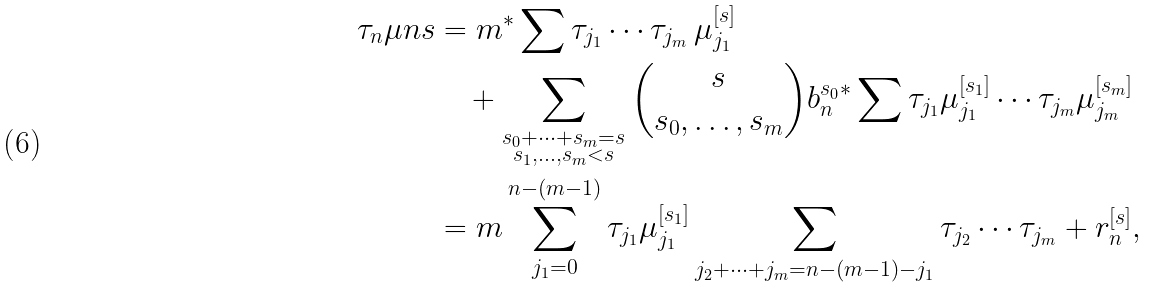Convert formula to latex. <formula><loc_0><loc_0><loc_500><loc_500>\tau _ { n } \mu n { s } & = m { ^ { * } } \sum \tau _ { j _ { 1 } } \cdots \tau _ { j _ { m } } \, \mu _ { j _ { 1 } } ^ { [ s ] } \\ & \quad + \sum _ { \substack { s _ { 0 } + \dots + s _ { m } = s \\ s _ { 1 } , \dots , s _ { m } < s } } \binom { s } { s _ { 0 } , \dots , s _ { m } } b _ { n } ^ { s _ { 0 } } { ^ { * } } \sum \tau _ { j _ { 1 } } \mu _ { j _ { 1 } } ^ { [ s _ { 1 } ] } \cdots \tau _ { j _ { m } } \mu _ { j _ { m } } ^ { [ s _ { m } ] } \\ & = m \sum _ { j _ { 1 } = 0 } ^ { n - ( m - 1 ) } \tau _ { j _ { 1 } } \mu _ { j _ { 1 } } ^ { [ s _ { 1 } ] } \sum _ { j _ { 2 } + \dots + j _ { m } = n - ( m - 1 ) - j _ { 1 } } \tau _ { j _ { 2 } } \cdots \tau _ { j _ { m } } + r _ { n } ^ { [ s ] } ,</formula> 